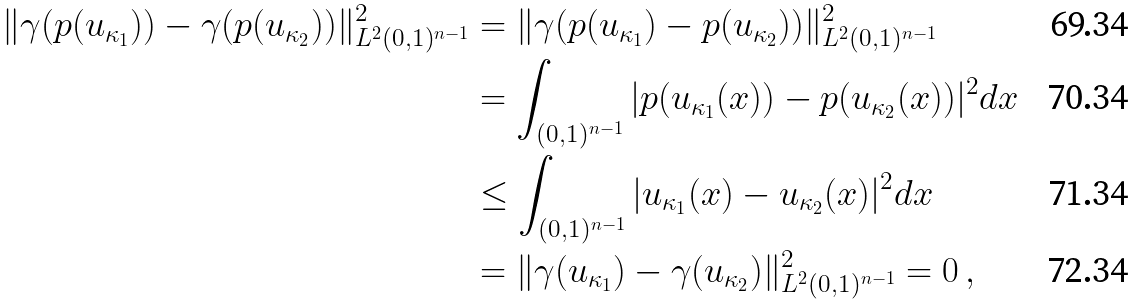<formula> <loc_0><loc_0><loc_500><loc_500>\| \gamma ( p ( u _ { \kappa _ { 1 } } ) ) - \gamma ( p ( u _ { \kappa _ { 2 } } ) ) \| _ { L ^ { 2 } ( 0 , 1 ) ^ { n - 1 } } ^ { 2 } & = \| \gamma ( p ( u _ { \kappa _ { 1 } } ) - p ( u _ { \kappa _ { 2 } } ) ) \| _ { L ^ { 2 } ( 0 , 1 ) ^ { n - 1 } } ^ { 2 } \\ & = \int _ { ( 0 , 1 ) ^ { n - 1 } } | p ( u _ { \kappa _ { 1 } } ( x ) ) - p ( u _ { \kappa _ { 2 } } ( x ) ) | ^ { 2 } d x \\ & \leq \int _ { ( 0 , 1 ) ^ { n - 1 } } | u _ { \kappa _ { 1 } } ( x ) - u _ { \kappa _ { 2 } } ( x ) | ^ { 2 } d x \\ & = \| \gamma ( u _ { \kappa _ { 1 } } ) - \gamma ( u _ { \kappa _ { 2 } } ) \| ^ { 2 } _ { L ^ { 2 } ( 0 , 1 ) ^ { n - 1 } } = 0 \, ,</formula> 